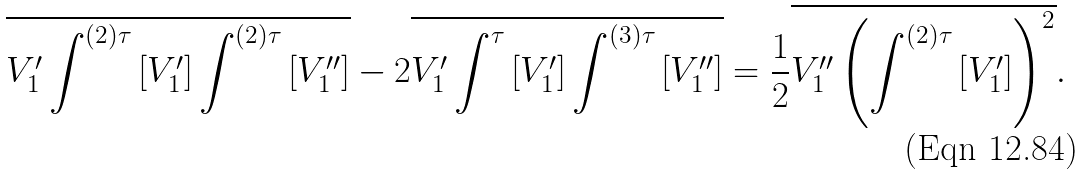Convert formula to latex. <formula><loc_0><loc_0><loc_500><loc_500>\overline { V _ { 1 } ^ { \prime } \int ^ { ( 2 ) \tau } \left [ V _ { 1 } ^ { \prime } \right ] \int ^ { ( 2 ) \tau } \left [ V _ { 1 } ^ { \prime \prime } \right ] } - 2 \overline { V _ { 1 } ^ { \prime } \int ^ { \tau } \left [ V _ { 1 } ^ { \prime } \right ] \int ^ { ( 3 ) \tau } \left [ V _ { 1 } ^ { \prime \prime } \right ] } = \frac { 1 } { 2 } \overline { V _ { 1 } ^ { \prime \prime } \left ( \int ^ { ( 2 ) \tau } \left [ V _ { 1 } ^ { \prime } \right ] \right ) ^ { 2 } } .</formula> 